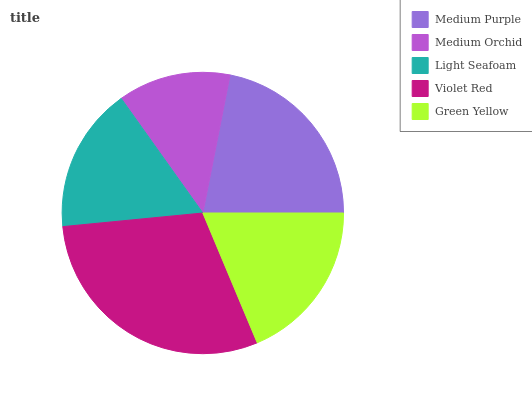Is Medium Orchid the minimum?
Answer yes or no. Yes. Is Violet Red the maximum?
Answer yes or no. Yes. Is Light Seafoam the minimum?
Answer yes or no. No. Is Light Seafoam the maximum?
Answer yes or no. No. Is Light Seafoam greater than Medium Orchid?
Answer yes or no. Yes. Is Medium Orchid less than Light Seafoam?
Answer yes or no. Yes. Is Medium Orchid greater than Light Seafoam?
Answer yes or no. No. Is Light Seafoam less than Medium Orchid?
Answer yes or no. No. Is Green Yellow the high median?
Answer yes or no. Yes. Is Green Yellow the low median?
Answer yes or no. Yes. Is Violet Red the high median?
Answer yes or no. No. Is Light Seafoam the low median?
Answer yes or no. No. 